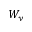<formula> <loc_0><loc_0><loc_500><loc_500>W _ { y }</formula> 